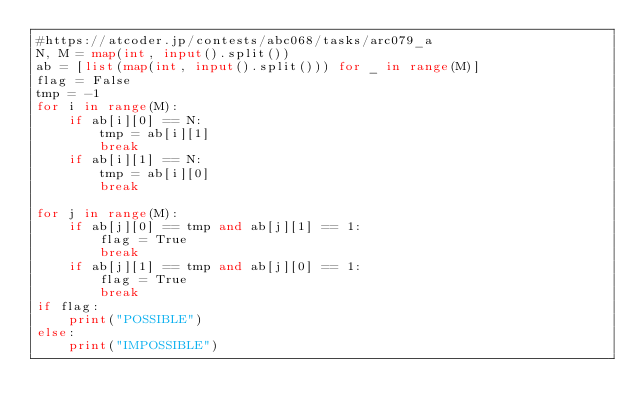Convert code to text. <code><loc_0><loc_0><loc_500><loc_500><_Python_>#https://atcoder.jp/contests/abc068/tasks/arc079_a
N, M = map(int, input().split())
ab = [list(map(int, input().split())) for _ in range(M)]
flag = False
tmp = -1
for i in range(M):
    if ab[i][0] == N:
        tmp = ab[i][1]
        break
    if ab[i][1] == N:
        tmp = ab[i][0]
        break

for j in range(M):
    if ab[j][0] == tmp and ab[j][1] == 1:
        flag = True
        break
    if ab[j][1] == tmp and ab[j][0] == 1:
        flag = True
        break
if flag:
    print("POSSIBLE")
else:
    print("IMPOSSIBLE")</code> 